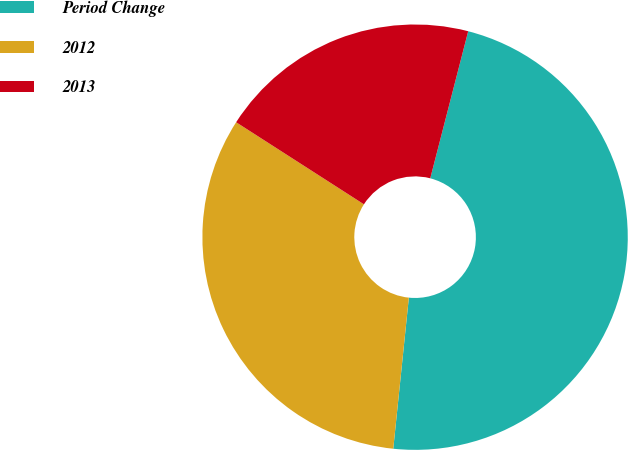Convert chart. <chart><loc_0><loc_0><loc_500><loc_500><pie_chart><fcel>Period Change<fcel>2012<fcel>2013<nl><fcel>47.62%<fcel>32.45%<fcel>19.93%<nl></chart> 